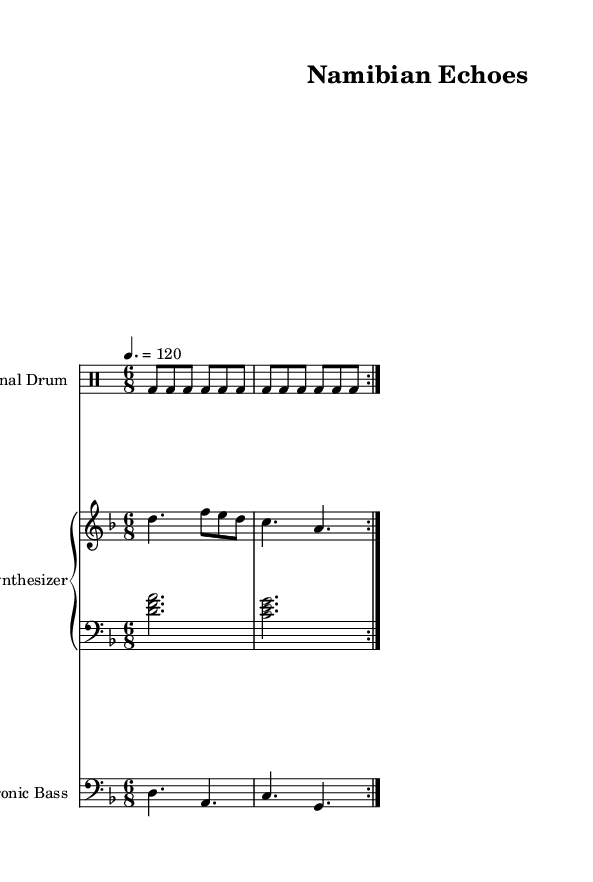What is the key signature of this music? The key signature is D minor, which has one flat (B flat) indicated at the beginning of the staff.
Answer: D minor What is the time signature of this music? The time signature is 6/8, indicated at the beginning of the music, which means there are six eighth notes in each measure.
Answer: 6/8 What is the tempo marking of this piece? The tempo marking indicates a speed of 120 beats per minute, which is noted above the staff as "4. = 120."
Answer: 120 How many measures are repeated in the traditional drum part? The traditional drum part includes two measures that are repeated, indicated by the "repeat volta 2" instruction.
Answer: 2 What is the highest note in the synthesizer melody? The highest note in the synthesizer melody is an F, which is the second note in the melodic line.
Answer: F What chord is played in the synthesizer harmony section? The synthesizer harmony section features a D minor chord, where the notes D, F, and A are played together in a two-note harmony.
Answer: D minor Which instrument plays the bass line? The electronic bass instrument plays the bass line, as indicated by its unique staff in the score.
Answer: Electronic Bass 